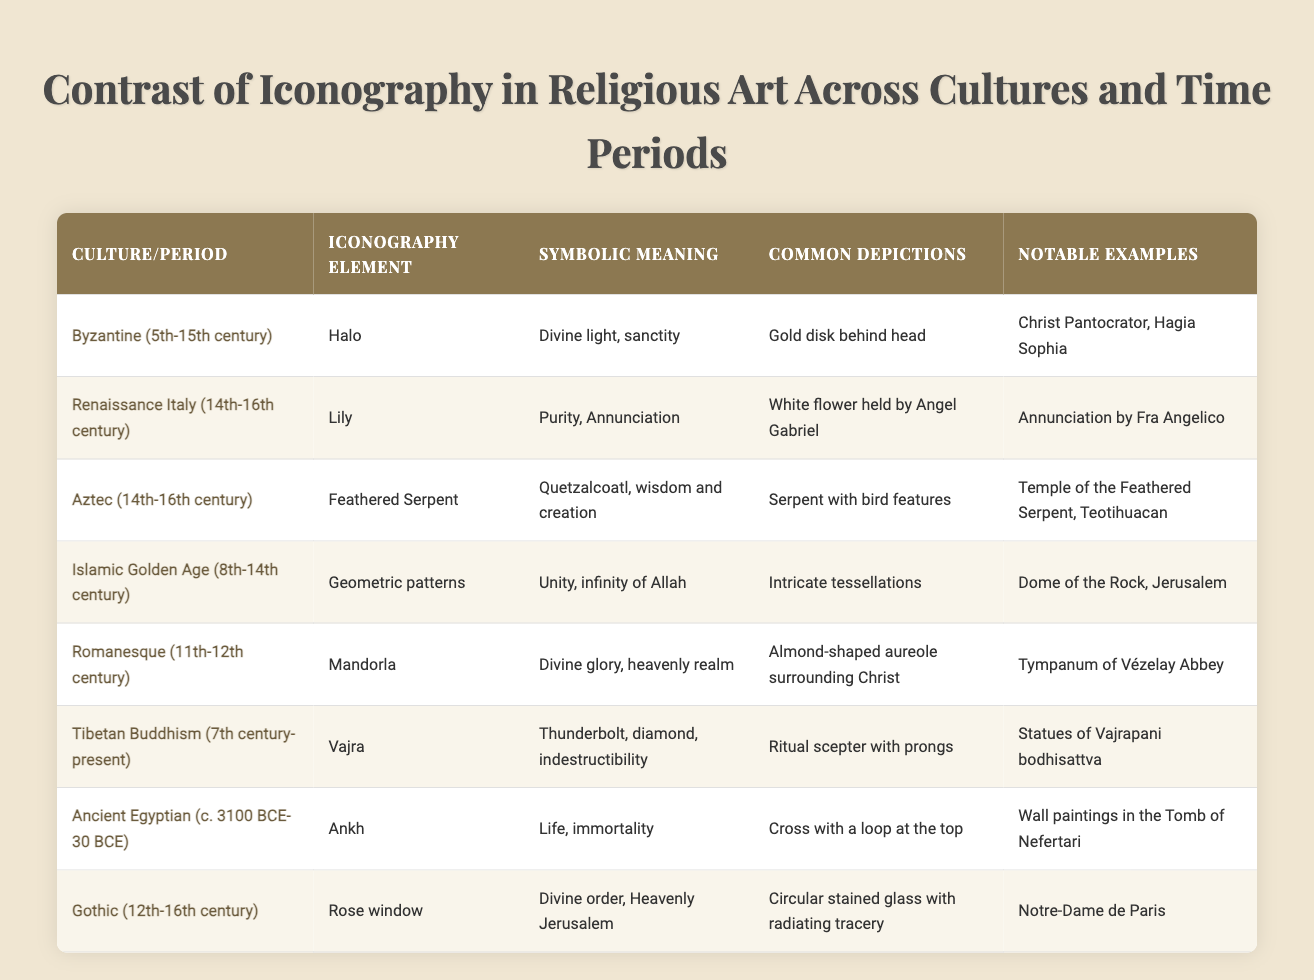What is the symbolic meaning of the halo in Byzantine art? The table states that the halo symbolizes divine light and sanctity in Byzantine art. This is a direct retrieval of information from the "Symbolic Meaning" column corresponding to the Byzantine row.
Answer: Divine light, sanctity Which culture/period features the feathered serpent in its iconography? The feathered serpent is listed under the Aztec row in the "Culture/Period" column. This is a straightforward retrieval question.
Answer: Aztec (14th-16th century) True or False: The mandorla symbolizes divine glory in Romanesque art. According to the table, the mandorla does symbolize divine glory, which means the statement is true. This is a simple fact-based question.
Answer: True What common depictions are associated with the lily in Renaissance Italian art? The table specifies that the common depiction for the lily is "white flower held by Angel Gabriel." This requires looking at the "Common Depictions" column for the Renaissance Italy row.
Answer: White flower held by Angel Gabriel Which iconography element is depicted as a "cross with a loop at the top"? This description fits the ankh, which is detailed in the Ancient Egyptian row under "Common Depictions." This requires retrieving specific information from that row.
Answer: Ankh How many different cultures or periods feature a symbol related to heavenly realms or divine power? The table shows that there are three relevant cultures: Byzantine (halo), Romanesque (mandorla), and Gothic (rose window). We count these entries from the rows where the symbolic meanings relate to divine aspects.
Answer: Three Which notable example corresponds to the geometric patterns of the Islamic Golden Age? The notable example listed in the table for the geometric patterns is the "Dome of the Rock, Jerusalem." This is a simple retrieval question based on the "Notable Examples" column.
Answer: Dome of the Rock, Jerusalem What is the relationship between the Vajra and its symbolic meaning? The Vajra, described in the Tibetan Buddhism row, symbolizes indestructibility, while its depiction includes a ritual scepter with prongs. This requires synthesizing the meaning and common depiction columns.
Answer: Symbolizes indestructibility, depicted as a ritual scepter with prongs 